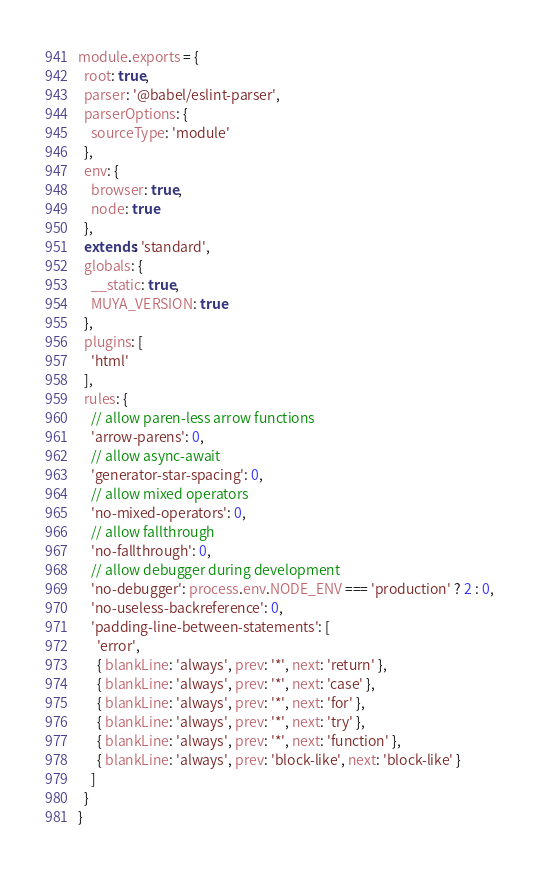Convert code to text. <code><loc_0><loc_0><loc_500><loc_500><_JavaScript_>module.exports = {
  root: true,
  parser: '@babel/eslint-parser',
  parserOptions: {
    sourceType: 'module'
  },
  env: {
    browser: true,
    node: true
  },
  extends: 'standard',
  globals: {
    __static: true,
    MUYA_VERSION: true
  },
  plugins: [
    'html'
  ],
  rules: {
    // allow paren-less arrow functions
    'arrow-parens': 0,
    // allow async-await
    'generator-star-spacing': 0,
    // allow mixed operators
    'no-mixed-operators': 0,
    // allow fallthrough
    'no-fallthrough': 0,
    // allow debugger during development
    'no-debugger': process.env.NODE_ENV === 'production' ? 2 : 0,
    'no-useless-backreference': 0,
    'padding-line-between-statements': [
      'error',
      { blankLine: 'always', prev: '*', next: 'return' },
      { blankLine: 'always', prev: '*', next: 'case' },
      { blankLine: 'always', prev: '*', next: 'for' },
      { blankLine: 'always', prev: '*', next: 'try' },
      { blankLine: 'always', prev: '*', next: 'function' },
      { blankLine: 'always', prev: 'block-like', next: 'block-like' }
    ]
  }
}
</code> 